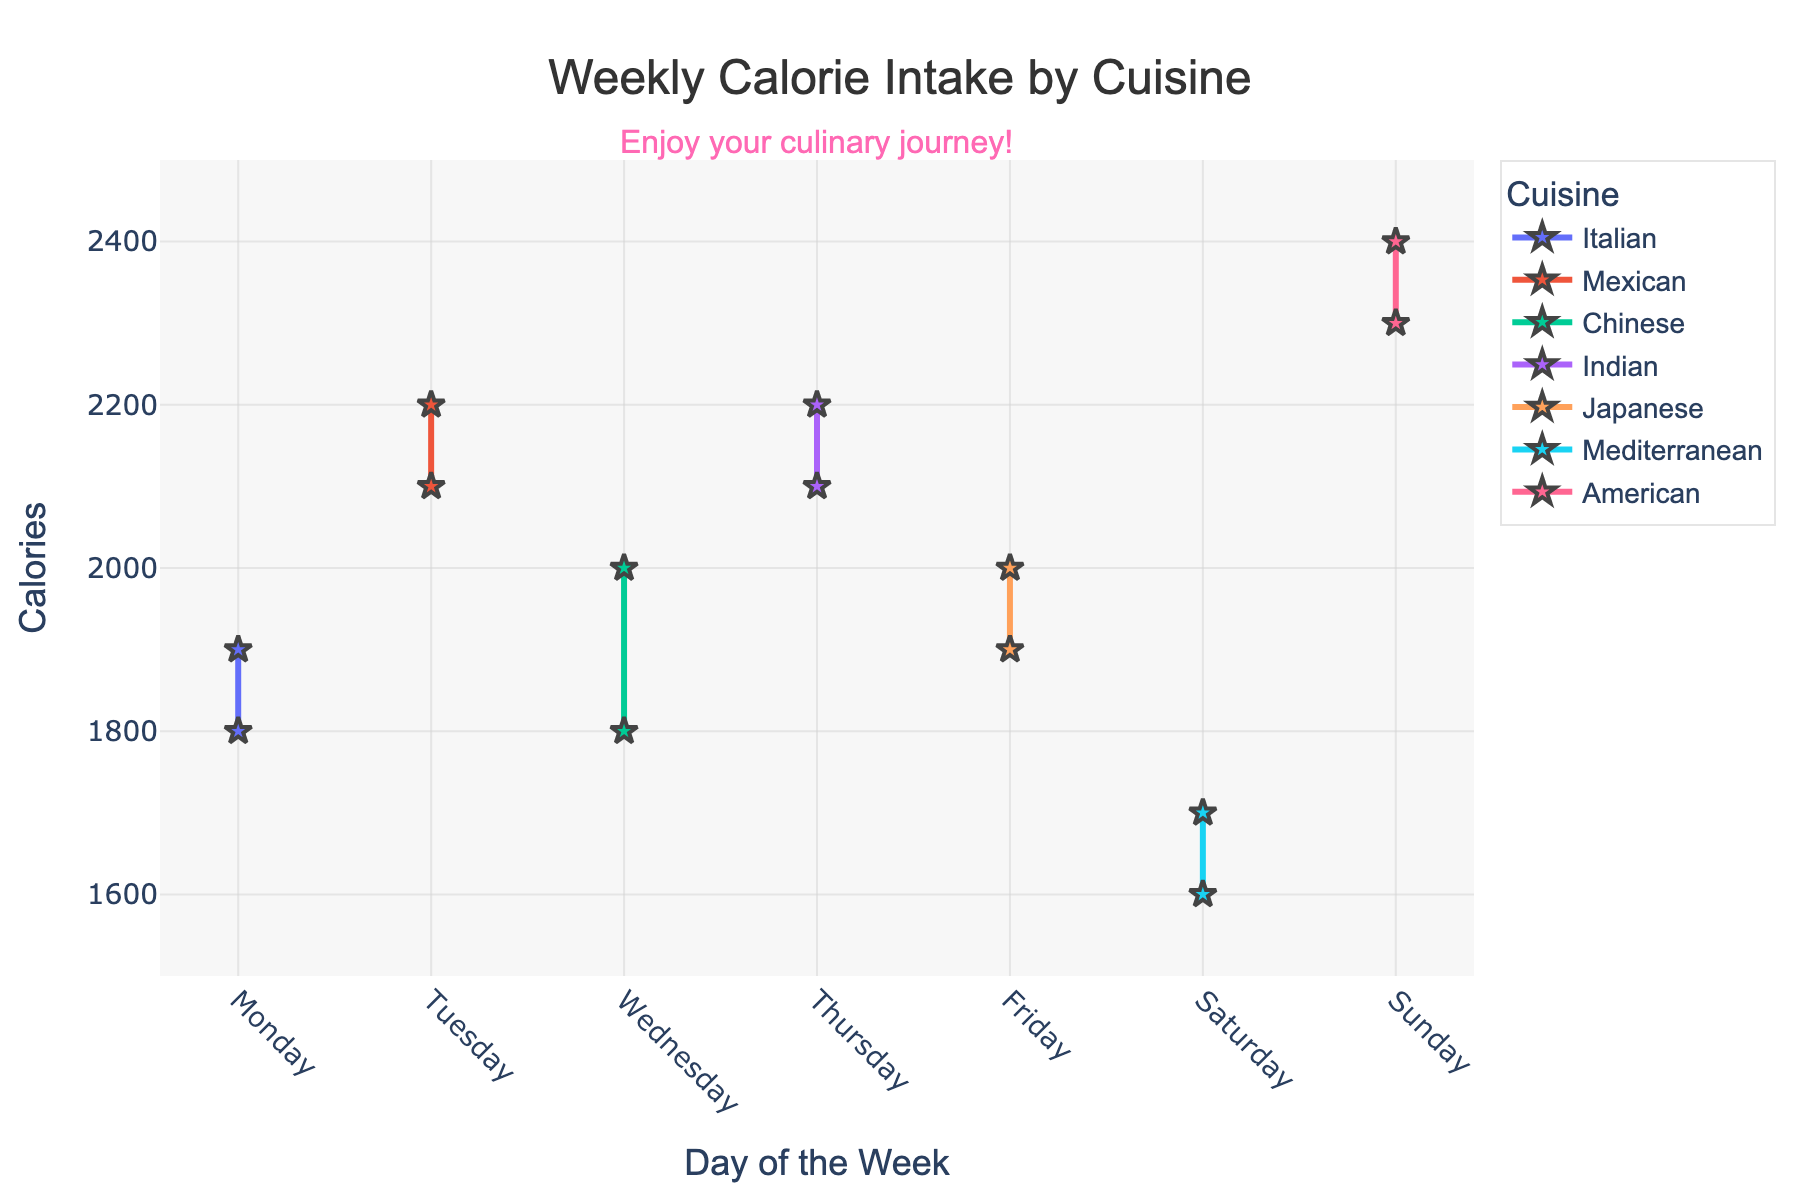What is the title of the plot? The title of the plot is displayed at the top center of the figure. It reads "Weekly Calorie Intake by Cuisine".
Answer: Weekly Calorie Intake by Cuisine On which day do you consume the most calories? From the figure, the day with the highest calorie intake for any cuisine is Sunday for American cuisine, which hovers around 2400 calories.
Answer: Sunday Which two cuisines have the closest calorie intake on Thursday? On Thursday, Indian cuisine has around 2100 calories, and Chinese cuisine has around 2200 calories. The difference is minimal compared to other cuisine pairs.
Answer: Indian and Chinese What is the average calorie intake for Japanese cuisine over the observed days? Japanese cuisine shows calorie values of around 1900 (Friday) and 2000 (Friday). The average can be calculated as (1900+2000)/2 = 1950.
Answer: 1950 Which cuisine has the greatest fluctuation in calorie intake over the week? By comparing the calorie ranges for each cuisine from Monday to Sunday, American cuisine shows the largest fluctuation with calories ranging from 2300 to 2400.
Answer: American What trend is common to the calorie intake for most cuisines from Monday to Sunday? Observing the plot, most cuisines tend to peak in calorie intake around the mid-week or towards the weekend, then slightly decrease.
Answer: Increase towards weekend How many different cuisines are displayed in the plot? The figure illustrates seven different cuisines represented by unique lines and markers: Italian, Mexican, Chinese, Indian, Japanese, Mediterranean, and American.
Answer: 7 Which day of the week has the highest collective calorie intake across all cuisines? Summing up the calories for each day, the total is highest on Sunday with calorie counts from Mediterranean, Japanese, and American cuisines being significant contributors.
Answer: Sunday If you had to reduce calorie intake on one day for health reasons, which day would you choose based on the plot? Considering calorie peaks, reducing intake on Sunday makes the most sense since it has the highest total intake across all cuisines.
Answer: Sunday 